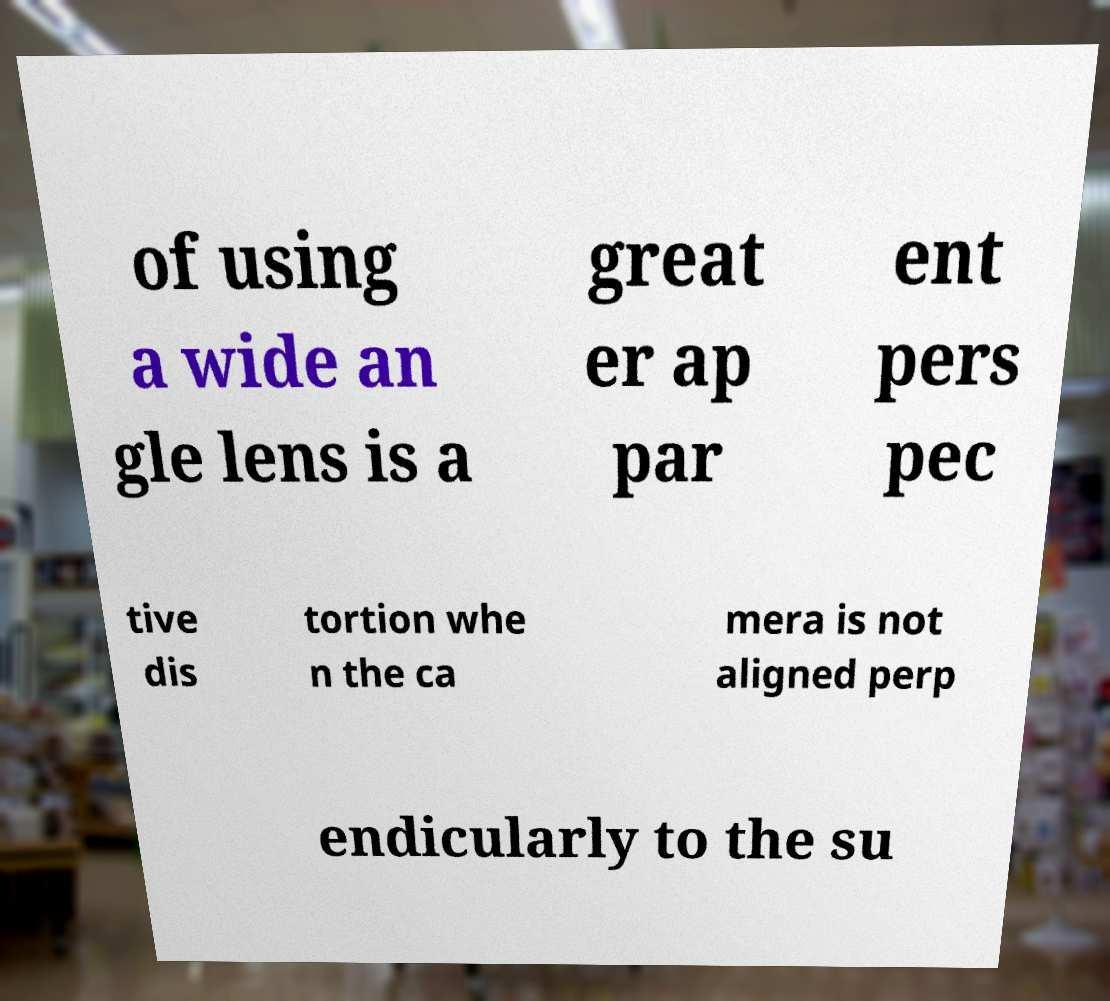For documentation purposes, I need the text within this image transcribed. Could you provide that? of using a wide an gle lens is a great er ap par ent pers pec tive dis tortion whe n the ca mera is not aligned perp endicularly to the su 